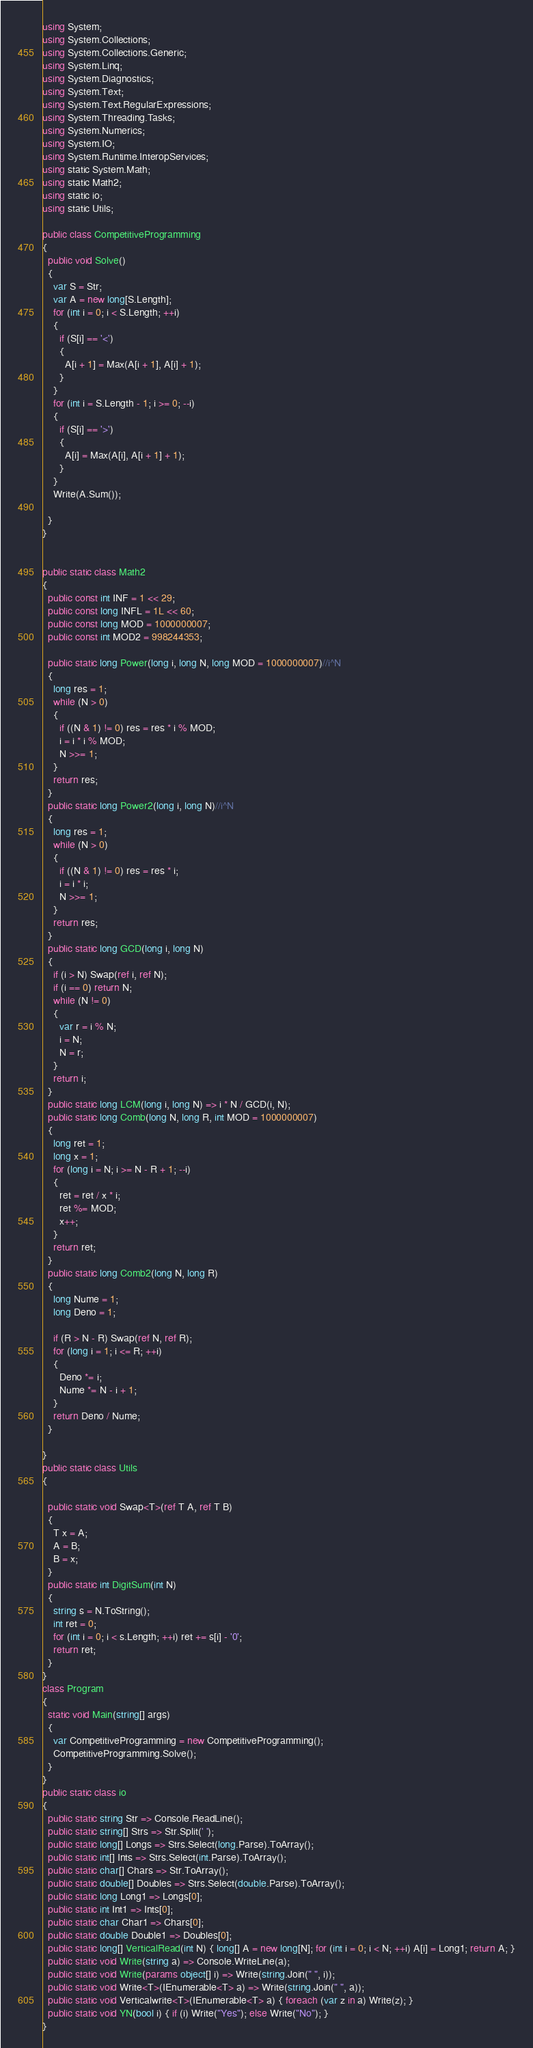<code> <loc_0><loc_0><loc_500><loc_500><_C#_>using System;
using System.Collections;
using System.Collections.Generic;
using System.Linq;
using System.Diagnostics;
using System.Text;
using System.Text.RegularExpressions;
using System.Threading.Tasks;
using System.Numerics;
using System.IO;
using System.Runtime.InteropServices;
using static System.Math;
using static Math2;
using static io;
using static Utils;

public class CompetitiveProgramming
{
  public void Solve()
  {
    var S = Str;
    var A = new long[S.Length];
    for (int i = 0; i < S.Length; ++i)
    {
      if (S[i] == '<')
      {
        A[i + 1] = Max(A[i + 1], A[i] + 1);
      }
    }
    for (int i = S.Length - 1; i >= 0; --i)
    {
      if (S[i] == '>')
      {
        A[i] = Max(A[i], A[i + 1] + 1);
      }
    }
    Write(A.Sum());

  }
}


public static class Math2
{
  public const int INF = 1 << 29;
  public const long INFL = 1L << 60;
  public const long MOD = 1000000007;
  public const int MOD2 = 998244353;

  public static long Power(long i, long N, long MOD = 1000000007)//i^N
  {
    long res = 1;
    while (N > 0)
    {
      if ((N & 1) != 0) res = res * i % MOD;
      i = i * i % MOD;
      N >>= 1;
    }
    return res;
  }
  public static long Power2(long i, long N)//i^N
  {
    long res = 1;
    while (N > 0)
    {
      if ((N & 1) != 0) res = res * i;
      i = i * i;
      N >>= 1;
    }
    return res;
  }
  public static long GCD(long i, long N)
  {
    if (i > N) Swap(ref i, ref N);
    if (i == 0) return N;
    while (N != 0)
    {
      var r = i % N;
      i = N;
      N = r;
    }
    return i;
  }
  public static long LCM(long i, long N) => i * N / GCD(i, N);
  public static long Comb(long N, long R, int MOD = 1000000007)
  {
    long ret = 1;
    long x = 1;
    for (long i = N; i >= N - R + 1; --i)
    {
      ret = ret / x * i;
      ret %= MOD;
      x++;
    }
    return ret;
  }
  public static long Comb2(long N, long R)
  {
    long Nume = 1;
    long Deno = 1;

    if (R > N - R) Swap(ref N, ref R);
    for (long i = 1; i <= R; ++i)
    {
      Deno *= i;
      Nume *= N - i + 1;
    }
    return Deno / Nume;
  }

}
public static class Utils
{

  public static void Swap<T>(ref T A, ref T B)
  {
    T x = A;
    A = B;
    B = x;
  }
  public static int DigitSum(int N)
  {
    string s = N.ToString();
    int ret = 0;
    for (int i = 0; i < s.Length; ++i) ret += s[i] - '0';
    return ret;
  }
}
class Program
{
  static void Main(string[] args)
  {
    var CompetitiveProgramming = new CompetitiveProgramming();
    CompetitiveProgramming.Solve();
  }
}
public static class io
{
  public static string Str => Console.ReadLine();
  public static string[] Strs => Str.Split(' ');
  public static long[] Longs => Strs.Select(long.Parse).ToArray();
  public static int[] Ints => Strs.Select(int.Parse).ToArray();
  public static char[] Chars => Str.ToArray();
  public static double[] Doubles => Strs.Select(double.Parse).ToArray();
  public static long Long1 => Longs[0];
  public static int Int1 => Ints[0];
  public static char Char1 => Chars[0];
  public static double Double1 => Doubles[0];
  public static long[] VerticalRead(int N) { long[] A = new long[N]; for (int i = 0; i < N; ++i) A[i] = Long1; return A; }
  public static void Write(string a) => Console.WriteLine(a);
  public static void Write(params object[] i) => Write(string.Join(" ", i));
  public static void Write<T>(IEnumerable<T> a) => Write(string.Join(" ", a));
  public static void Verticalwrite<T>(IEnumerable<T> a) { foreach (var z in a) Write(z); }
  public static void YN(bool i) { if (i) Write("Yes"); else Write("No"); }
}
</code> 